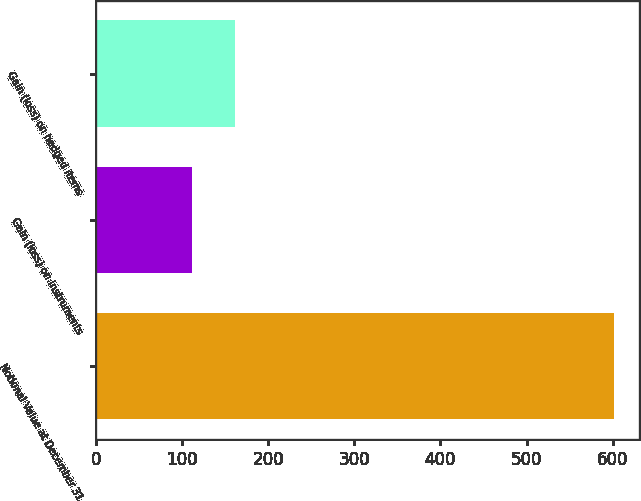Convert chart to OTSL. <chart><loc_0><loc_0><loc_500><loc_500><bar_chart><fcel>Notional Value at December 31<fcel>Gain (loss) on instruments<fcel>Gain (loss) on hedged items<nl><fcel>601<fcel>112<fcel>160.9<nl></chart> 